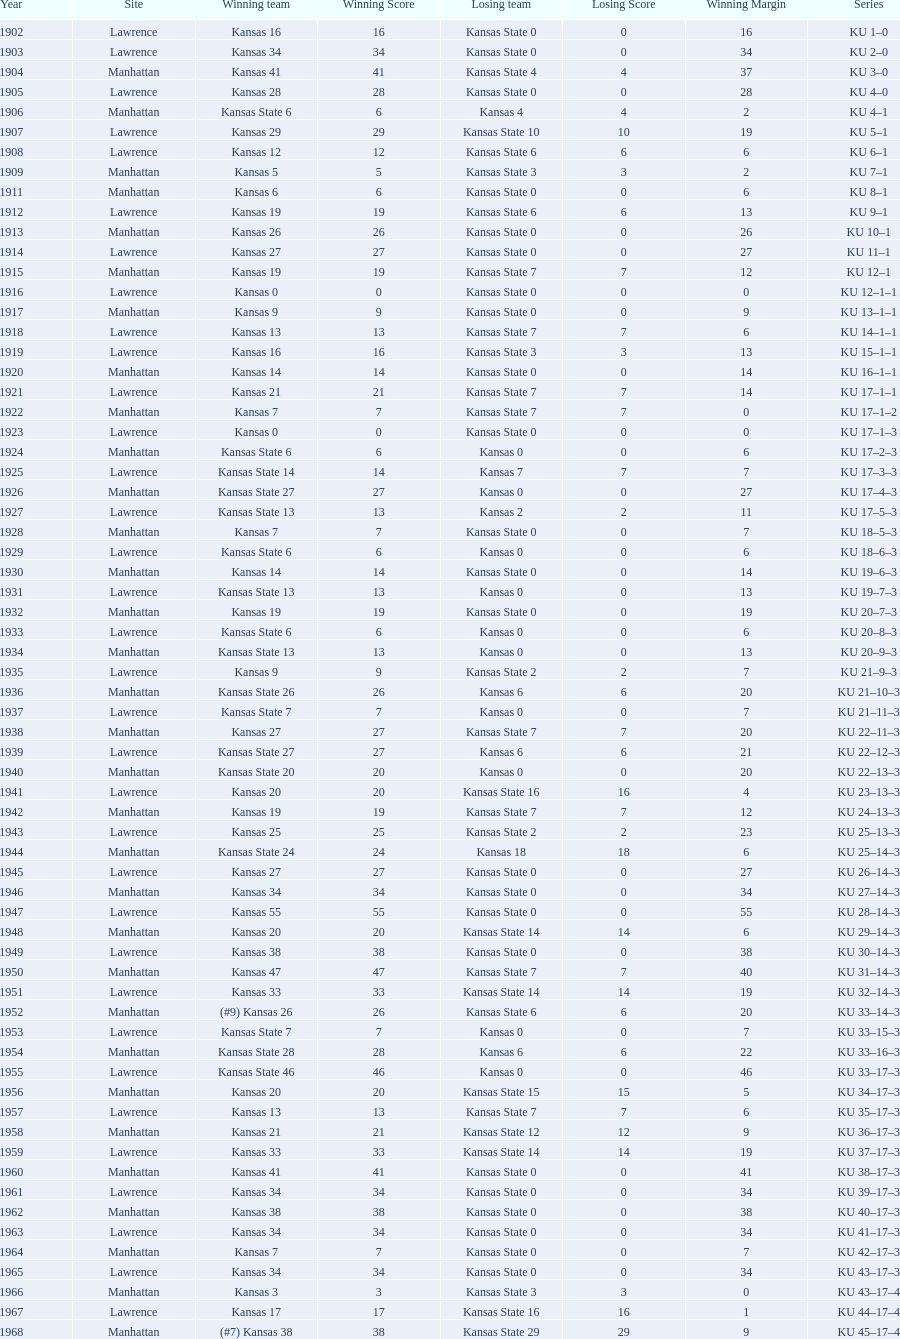Who had the most wins in the 1950's: kansas or kansas state? Kansas. 